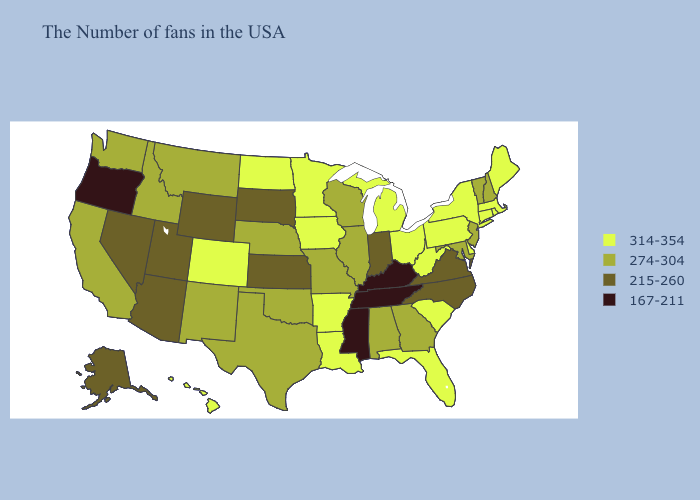What is the value of Mississippi?
Concise answer only. 167-211. What is the lowest value in states that border Iowa?
Answer briefly. 215-260. What is the highest value in the Northeast ?
Write a very short answer. 314-354. Among the states that border New Jersey , which have the highest value?
Concise answer only. New York, Delaware, Pennsylvania. Name the states that have a value in the range 314-354?
Quick response, please. Maine, Massachusetts, Rhode Island, Connecticut, New York, Delaware, Pennsylvania, South Carolina, West Virginia, Ohio, Florida, Michigan, Louisiana, Arkansas, Minnesota, Iowa, North Dakota, Colorado, Hawaii. Does Delaware have the highest value in the USA?
Concise answer only. Yes. What is the lowest value in the West?
Short answer required. 167-211. What is the lowest value in states that border Nebraska?
Quick response, please. 215-260. What is the value of New Hampshire?
Concise answer only. 274-304. Name the states that have a value in the range 314-354?
Quick response, please. Maine, Massachusetts, Rhode Island, Connecticut, New York, Delaware, Pennsylvania, South Carolina, West Virginia, Ohio, Florida, Michigan, Louisiana, Arkansas, Minnesota, Iowa, North Dakota, Colorado, Hawaii. Among the states that border Virginia , which have the highest value?
Quick response, please. West Virginia. What is the highest value in the West ?
Concise answer only. 314-354. Name the states that have a value in the range 167-211?
Quick response, please. Kentucky, Tennessee, Mississippi, Oregon. What is the value of Missouri?
Be succinct. 274-304. What is the value of South Dakota?
Short answer required. 215-260. 